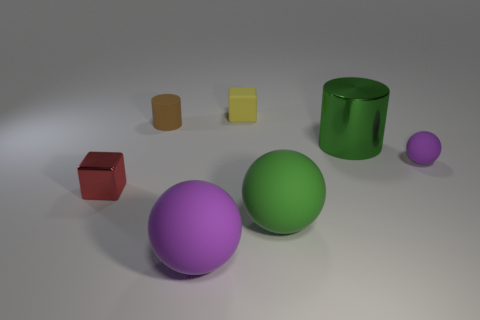Does the yellow block have the same material as the large cylinder?
Your answer should be compact. No. What is the color of the block in front of the tiny matte object that is left of the large purple thing?
Your answer should be very brief. Red. What is the size of the green object that is made of the same material as the yellow thing?
Provide a short and direct response. Large. What number of other large matte things have the same shape as the red thing?
Make the answer very short. 0. What number of objects are large things in front of the tiny purple rubber object or big green objects behind the green matte object?
Keep it short and to the point. 3. What number of large things are behind the purple ball right of the yellow thing?
Ensure brevity in your answer.  1. There is a yellow rubber thing behind the brown rubber cylinder; is it the same shape as the red metallic object that is in front of the small yellow thing?
Provide a succinct answer. Yes. What is the shape of the big rubber thing that is the same color as the small rubber ball?
Give a very brief answer. Sphere. Is there a tiny yellow thing made of the same material as the large green ball?
Your answer should be very brief. Yes. What number of metallic things are cylinders or yellow balls?
Keep it short and to the point. 1. 